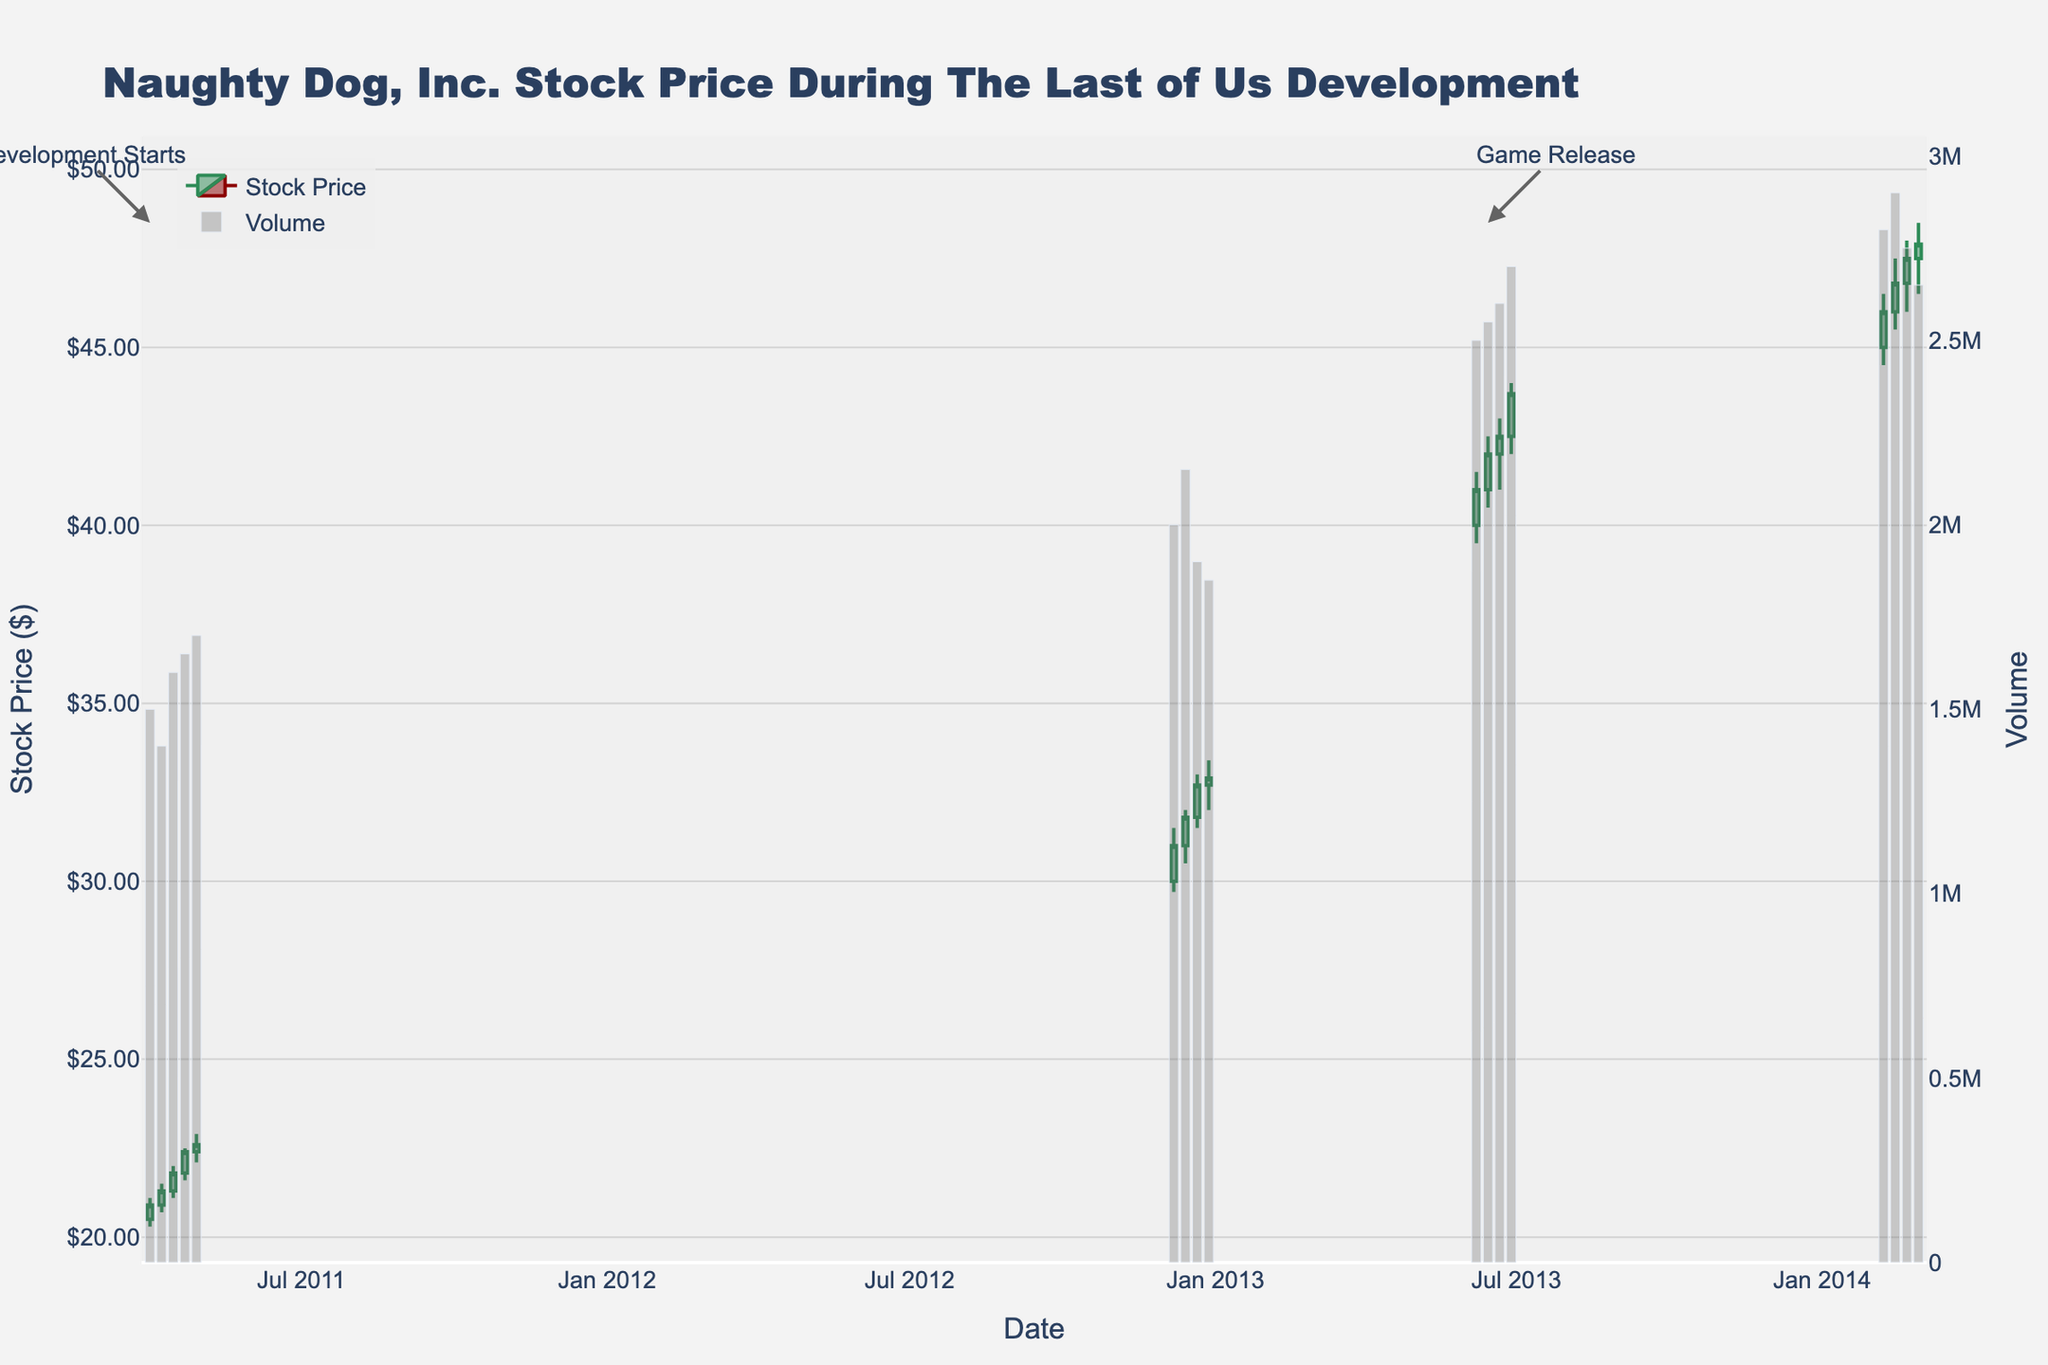What is the title of the plot? The title is typically displayed at the top of the plot. In this case, it reads 'Naughty Dog, Inc. Stock Price During The Last of Us Development.'
Answer: Naughty Dog, Inc. Stock Price During The Last of Us Development What date marks the beginning of the development period for The Last of Us? A clear annotation on the plot marks 'Development Starts' near the date 2011-04-01.
Answer: 2011-04-01 What is the stock price at the close on the date of the game's release? The game release is marked by the annotation on 2013-06-14. The closing price on that date can be read directly from the candlestick plotting close values.
Answer: $42.00 How did the stock price change from the start to the end of April 2011? To answer, look at the closing prices on 2011-04-01 and 2011-04-29. On 2011-04-01, the close was $20.90 and on 2011-04-29, it was $22.60. Subtract the starting price from the end price.
Answer: $1.70 (22.60 - 20.90) Comparing the volume of stock traded between the first week of development and the first week of release, which was higher? Check the annotation for development start (2011-04-01) and release (2013-06-14) and their corresponding volumes in the bar chart. Volume on 2011-04-01 was 1,500,000 and on 2013-06-14 it was 2,550,000.
Answer: Release week (2013-06-14) What was the highest stock price recorded in the provided data? Identify the maximum value in the 'High' column. On 2014-02-14, the high was $47.50, which appears to be the highest value in the range.
Answer: $48.00 Across the indicated development and release periods, by how much did the stock price increase overall? Check the close price on the date development started (2011-04-01: $20.90) and the close price on the last date in the dataset (2014-02-28: $47.90). Subtract the former from the latter.
Answer: $27.00 (47.90 - 20.90) What is the average closing price during December 2012? There are four closing prices in December 2012: 31.00, 31.80, 32.70, and 32.90. Add these and divide by four to get the average.
Answer: $32.10 ((31.00 + 31.80 + 32.70 + 32.90) / 4) How many weeks show an increase in stock price from their open to close values? Count the weeks where the close value is greater than the open value. The weeks with increasing prices are: 2011-04-08, 2011-04-15, 2011-04-22, 2012-12-14, 2012-12-21, 2013-06-07, 2013-06-14, 2013-06-21, 2014-02-14, 2014-02-21, and 2014-02-28.
Answer: 11 weeks 